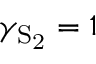<formula> <loc_0><loc_0><loc_500><loc_500>\gamma _ { S _ { 2 } } = 1</formula> 